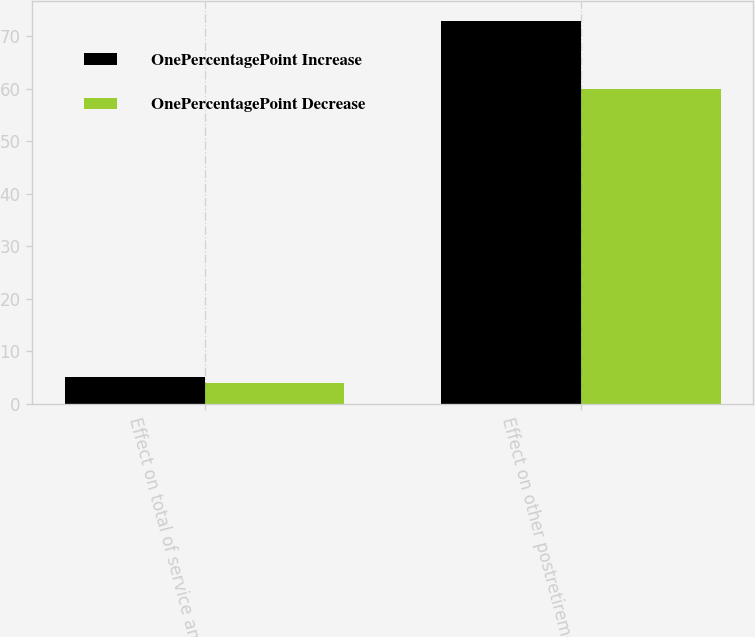Convert chart. <chart><loc_0><loc_0><loc_500><loc_500><stacked_bar_chart><ecel><fcel>Effect on total of service and<fcel>Effect on other postretirement<nl><fcel>OnePercentagePoint Increase<fcel>5<fcel>73<nl><fcel>OnePercentagePoint Decrease<fcel>4<fcel>60<nl></chart> 